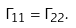Convert formula to latex. <formula><loc_0><loc_0><loc_500><loc_500>\Gamma _ { 1 1 } = \Gamma _ { 2 2 } .</formula> 